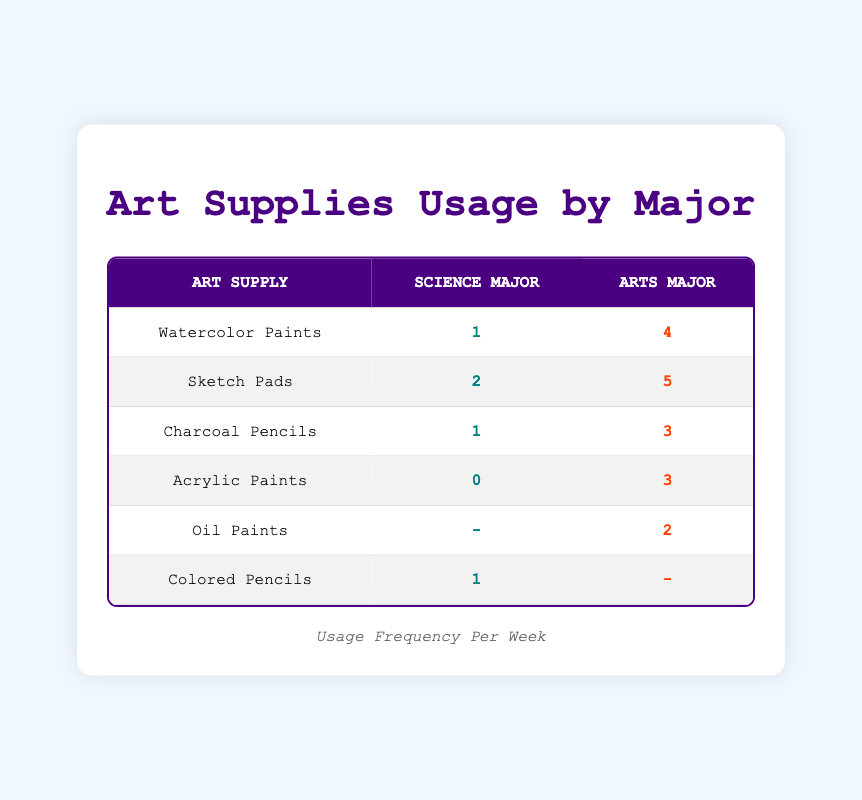What is the usage frequency of Acrylic Paints for Science majors? In the table, under the row for Acrylic Paints, the column for Science Major shows a usage frequency of 0.
Answer: 0 How many times do Arts majors use Sketch Pads per week? In the row for Sketch Pads, the Arts Major column indicates a usage frequency of 5.
Answer: 5 What is the sum of the usage frequency of Charcoal Pencils for both majors? The usage frequency for Charcoal Pencils in the Science column is 1, and in the Arts column, it is 3. Adding these together gives 1 + 3 = 4.
Answer: 4 Is the usage frequency of Oil Paints higher for Arts majors than that of Colored Pencils for Science majors? The usage frequency for Oil Paints under the Arts column is 2, and for Colored Pencils under the Science column is 1. Since 2 is greater than 1, the statement is true.
Answer: Yes What is the average usage frequency of Watercolor Paints and Acrylic Paints for Arts majors? For Watercolor Paints, the frequency is 4 and for Acrylic Paints, it is 3. The sum of both frequencies is 4 + 3 = 7. Since there are 2 data points, the average is 7 / 2 = 3.5.
Answer: 3.5 How many art supplies have a usage frequency greater than 3 for Arts majors? Looking at the table, the art supplies with a usage frequency greater than 3 for Arts majors are Sketch Pads (5), Watercolor Paints (4), and Charcoal Pencils (3). Thus, there are three supplies.
Answer: 3 What is the difference in usage frequency of Watercolor Paints between Science and Arts majors? The usage frequency for Watercolor Paints is 1 for Science majors and 4 for Arts majors. The difference is calculated as 4 - 1 = 3.
Answer: 3 Does any supply have a usage frequency of 0 for Arts majors? Referring to the table, the column for Arts majors does not list any supplies with a frequency of 0. Therefore, the answer is false.
Answer: No What is the total usage frequency for Science majors across all art supplies listed? Adding all the usage frequencies for Science majors: Watercolor Paints (1) + Sketch Pads (2) + Charcoal Pencils (1) + Acrylic Paints (0) + Colored Pencils (1) = 5.
Answer: 5 